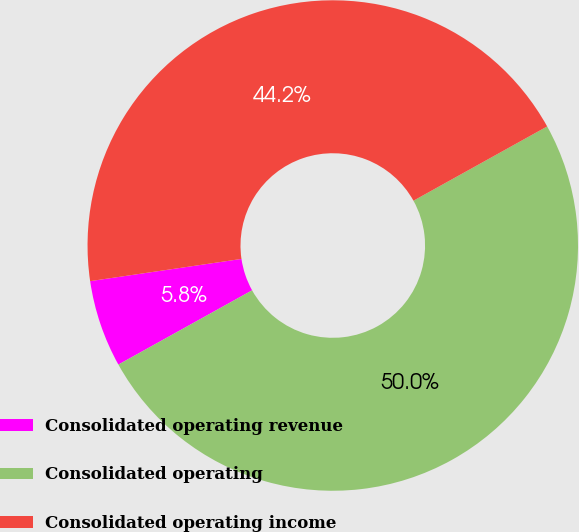Convert chart. <chart><loc_0><loc_0><loc_500><loc_500><pie_chart><fcel>Consolidated operating revenue<fcel>Consolidated operating<fcel>Consolidated operating income<nl><fcel>5.75%<fcel>50.0%<fcel>44.25%<nl></chart> 